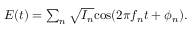Convert formula to latex. <formula><loc_0><loc_0><loc_500><loc_500>\begin{array} { r } { E ( t ) = \sum _ { n } \sqrt { I _ { n } } \cos ( 2 \pi f _ { n } t + \phi _ { n } ) . } \end{array}</formula> 